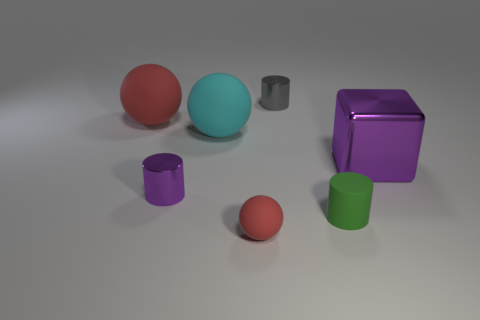There is a cyan matte object; what shape is it?
Your response must be concise. Sphere. There is a ball that is to the left of the cyan rubber object; what color is it?
Offer a terse response. Red. Does the gray cylinder to the left of the purple shiny cube have the same size as the purple cylinder?
Make the answer very short. Yes. The purple metal thing that is the same shape as the tiny gray thing is what size?
Offer a terse response. Small. Is there any other thing that is the same size as the matte cylinder?
Your response must be concise. Yes. Is the shape of the small gray object the same as the small purple shiny object?
Make the answer very short. Yes. Are there fewer big metal blocks that are to the left of the green thing than green rubber objects that are in front of the small red matte object?
Ensure brevity in your answer.  No. What number of objects are to the right of the matte cylinder?
Offer a very short reply. 1. There is a tiny rubber thing on the left side of the green object; does it have the same shape as the small metal thing behind the big red thing?
Offer a terse response. No. What number of other objects are the same color as the matte cylinder?
Make the answer very short. 0. 